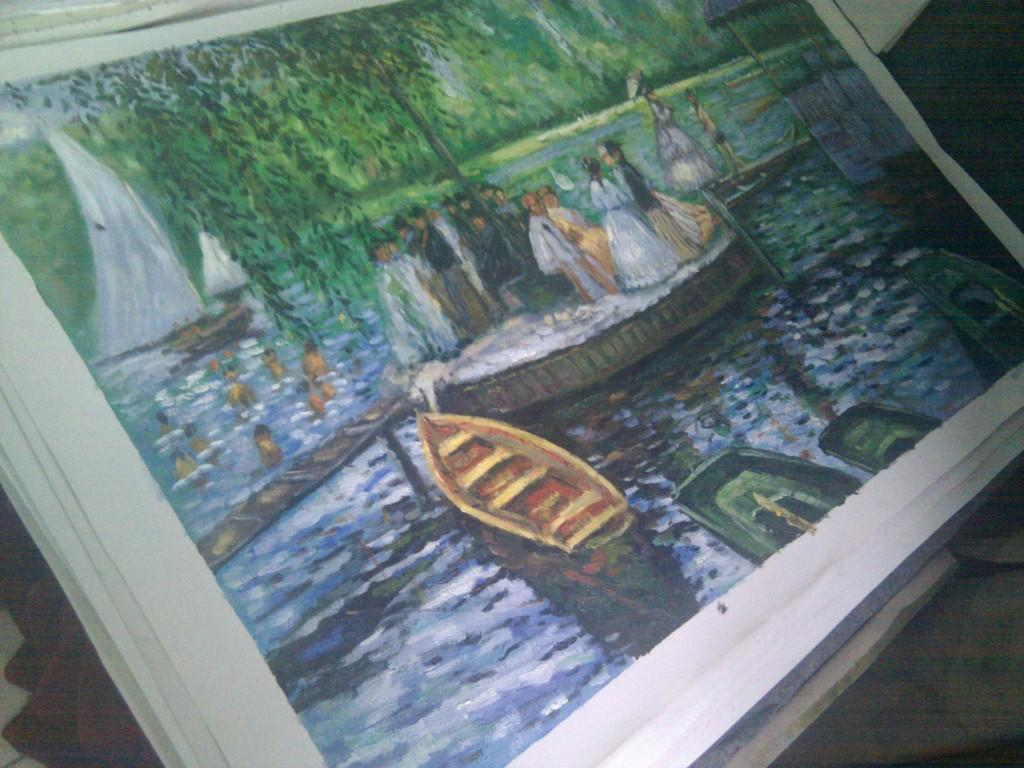What type of image is being described? The image is a drawing. What can be seen in the drawing? There are people standing in the drawing, and there are boats in the water. How many cows are present in the drawing? There are no cows present in the drawing; it features people and boats. Can you describe the interaction between the people in the drawing? The provided facts do not give information about the interaction between the people in the drawing. 